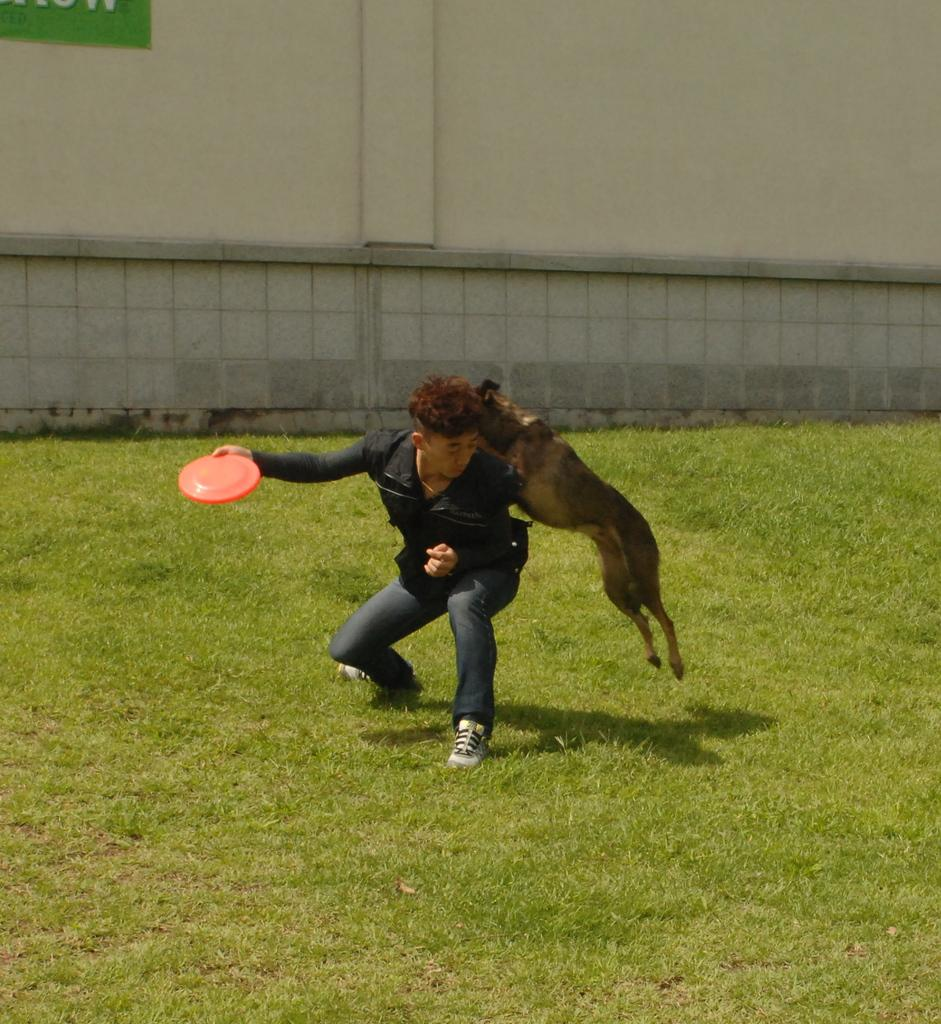What animal is the main subject of the image? There is a dog in the image. What is the dog attempting to do in the image? The dog is trying to catch a Frisbee. How is the dog interacting with the boy in the image? The dog is jumping over the boy. What can be seen in the background of the image? There is a wall in the background of the image. What type of tools does the pig use to build the rabbits' houses in the image? There is no pig, tools, or rabbits present in the image; it features a dog trying to catch a Frisbee while jumping over a boy. 